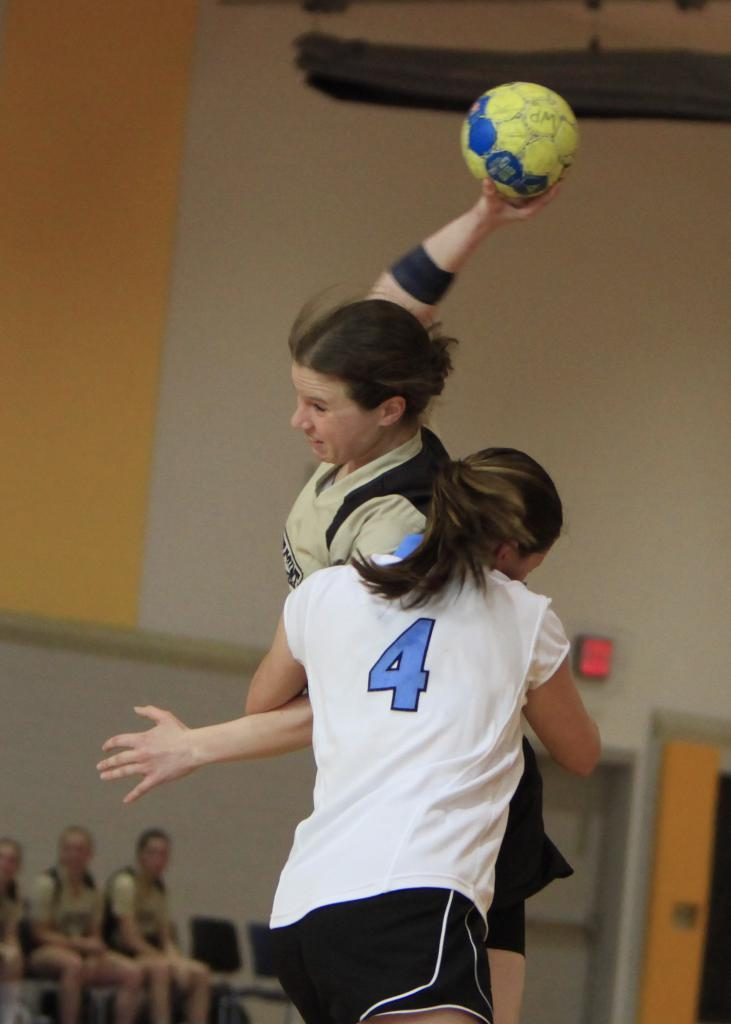<image>
Write a terse but informative summary of the picture. A girl wearing a jersey with a 4 on it looking like she is going to tackle another girl. 